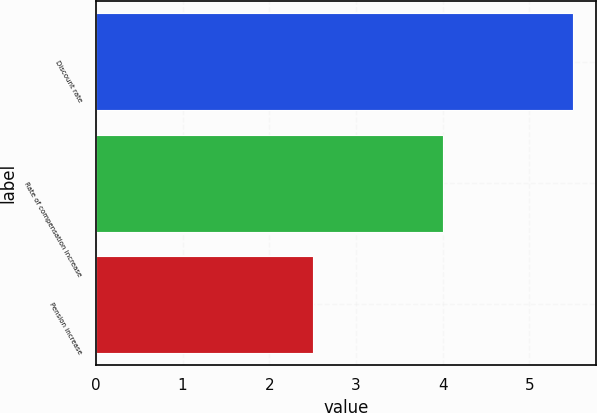<chart> <loc_0><loc_0><loc_500><loc_500><bar_chart><fcel>Discount rate<fcel>Rate of compensation increase<fcel>Pension increase<nl><fcel>5.5<fcel>4<fcel>2.5<nl></chart> 